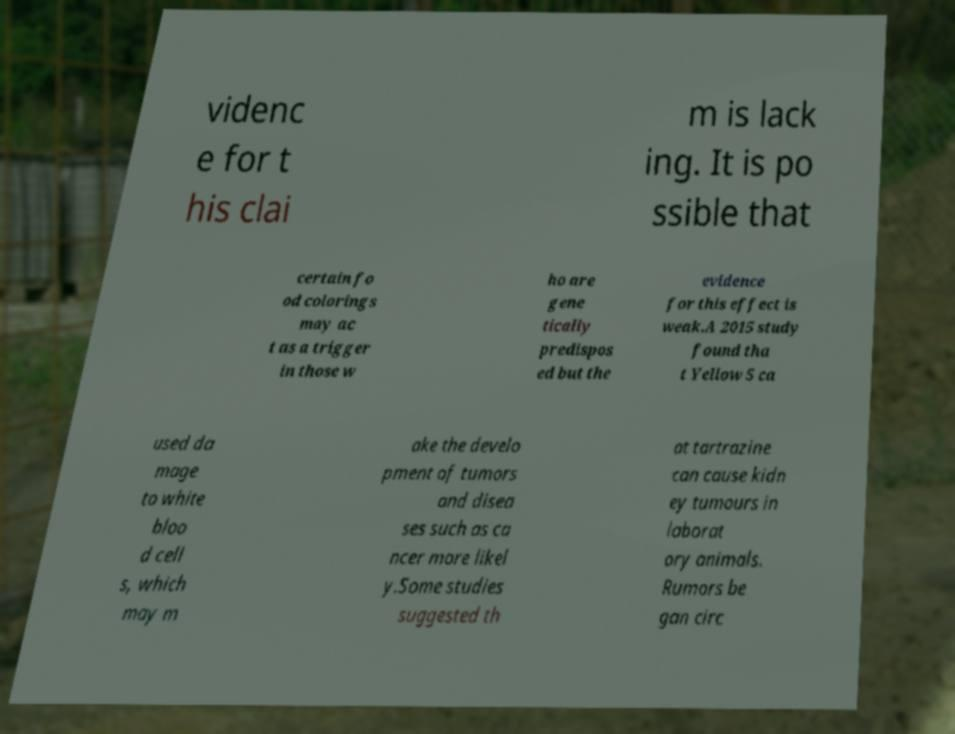Please read and relay the text visible in this image. What does it say? videnc e for t his clai m is lack ing. It is po ssible that certain fo od colorings may ac t as a trigger in those w ho are gene tically predispos ed but the evidence for this effect is weak.A 2015 study found tha t Yellow 5 ca used da mage to white bloo d cell s, which may m ake the develo pment of tumors and disea ses such as ca ncer more likel y.Some studies suggested th at tartrazine can cause kidn ey tumours in laborat ory animals. Rumors be gan circ 